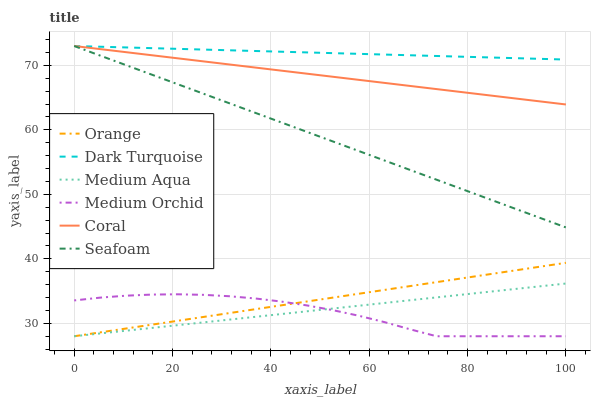Does Medium Orchid have the minimum area under the curve?
Answer yes or no. Yes. Does Dark Turquoise have the maximum area under the curve?
Answer yes or no. Yes. Does Coral have the minimum area under the curve?
Answer yes or no. No. Does Coral have the maximum area under the curve?
Answer yes or no. No. Is Orange the smoothest?
Answer yes or no. Yes. Is Medium Orchid the roughest?
Answer yes or no. Yes. Is Coral the smoothest?
Answer yes or no. No. Is Coral the roughest?
Answer yes or no. No. Does Medium Orchid have the lowest value?
Answer yes or no. Yes. Does Coral have the lowest value?
Answer yes or no. No. Does Seafoam have the highest value?
Answer yes or no. Yes. Does Medium Orchid have the highest value?
Answer yes or no. No. Is Medium Orchid less than Dark Turquoise?
Answer yes or no. Yes. Is Dark Turquoise greater than Medium Aqua?
Answer yes or no. Yes. Does Orange intersect Medium Orchid?
Answer yes or no. Yes. Is Orange less than Medium Orchid?
Answer yes or no. No. Is Orange greater than Medium Orchid?
Answer yes or no. No. Does Medium Orchid intersect Dark Turquoise?
Answer yes or no. No. 